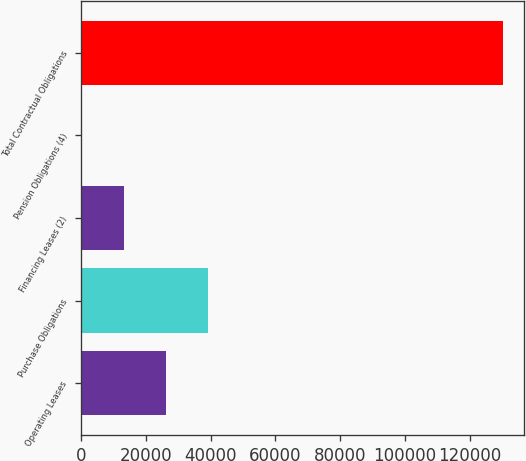Convert chart. <chart><loc_0><loc_0><loc_500><loc_500><bar_chart><fcel>Operating Leases<fcel>Purchase Obligations<fcel>Financing Leases (2)<fcel>Pension Obligations (4)<fcel>Total Contractual Obligations<nl><fcel>26339<fcel>39342.5<fcel>13335.5<fcel>332<fcel>130367<nl></chart> 